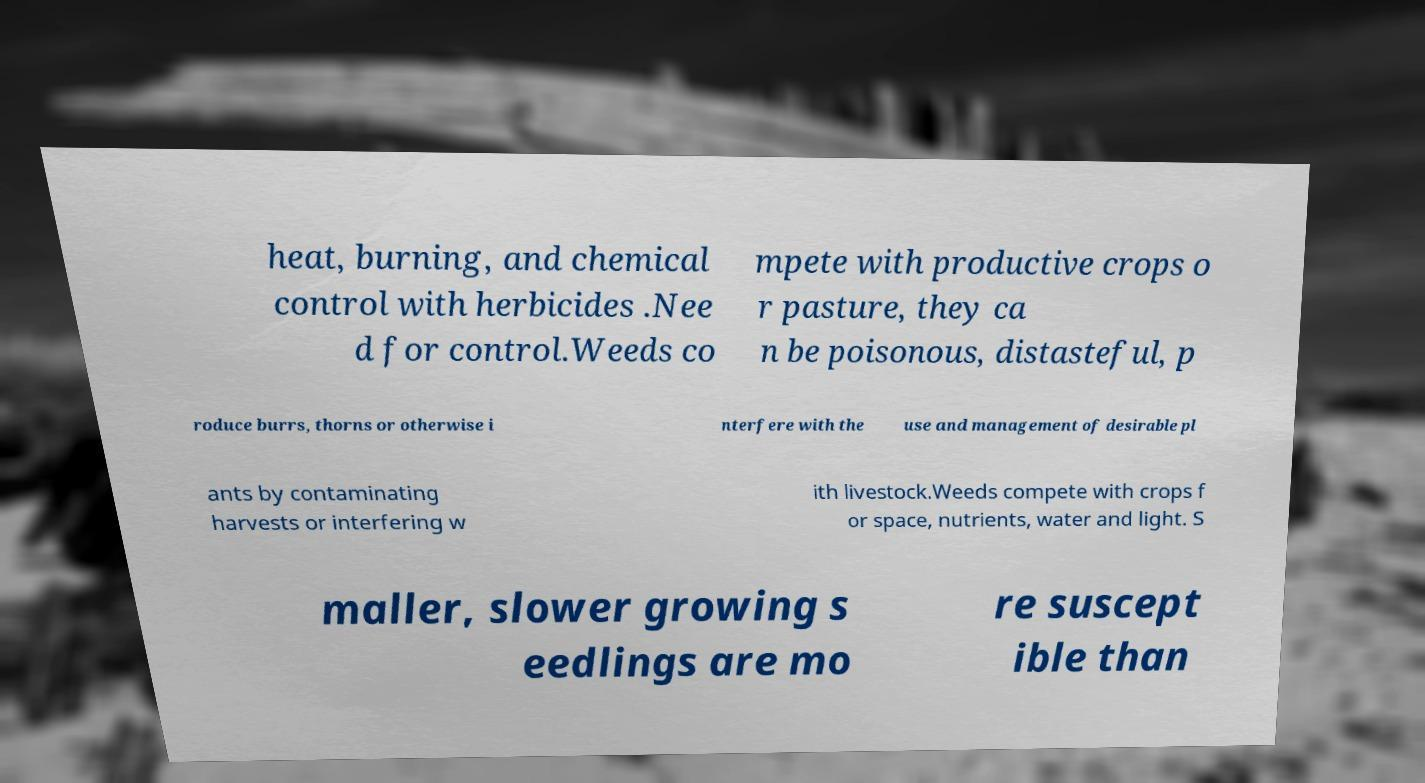Could you extract and type out the text from this image? heat, burning, and chemical control with herbicides .Nee d for control.Weeds co mpete with productive crops o r pasture, they ca n be poisonous, distasteful, p roduce burrs, thorns or otherwise i nterfere with the use and management of desirable pl ants by contaminating harvests or interfering w ith livestock.Weeds compete with crops f or space, nutrients, water and light. S maller, slower growing s eedlings are mo re suscept ible than 